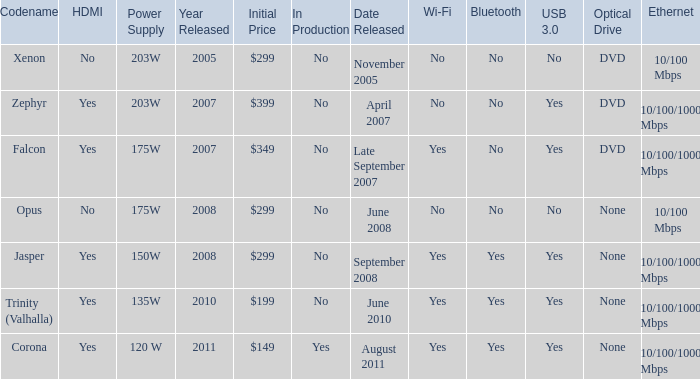Does Trinity (valhalla) have HDMI? Yes. 